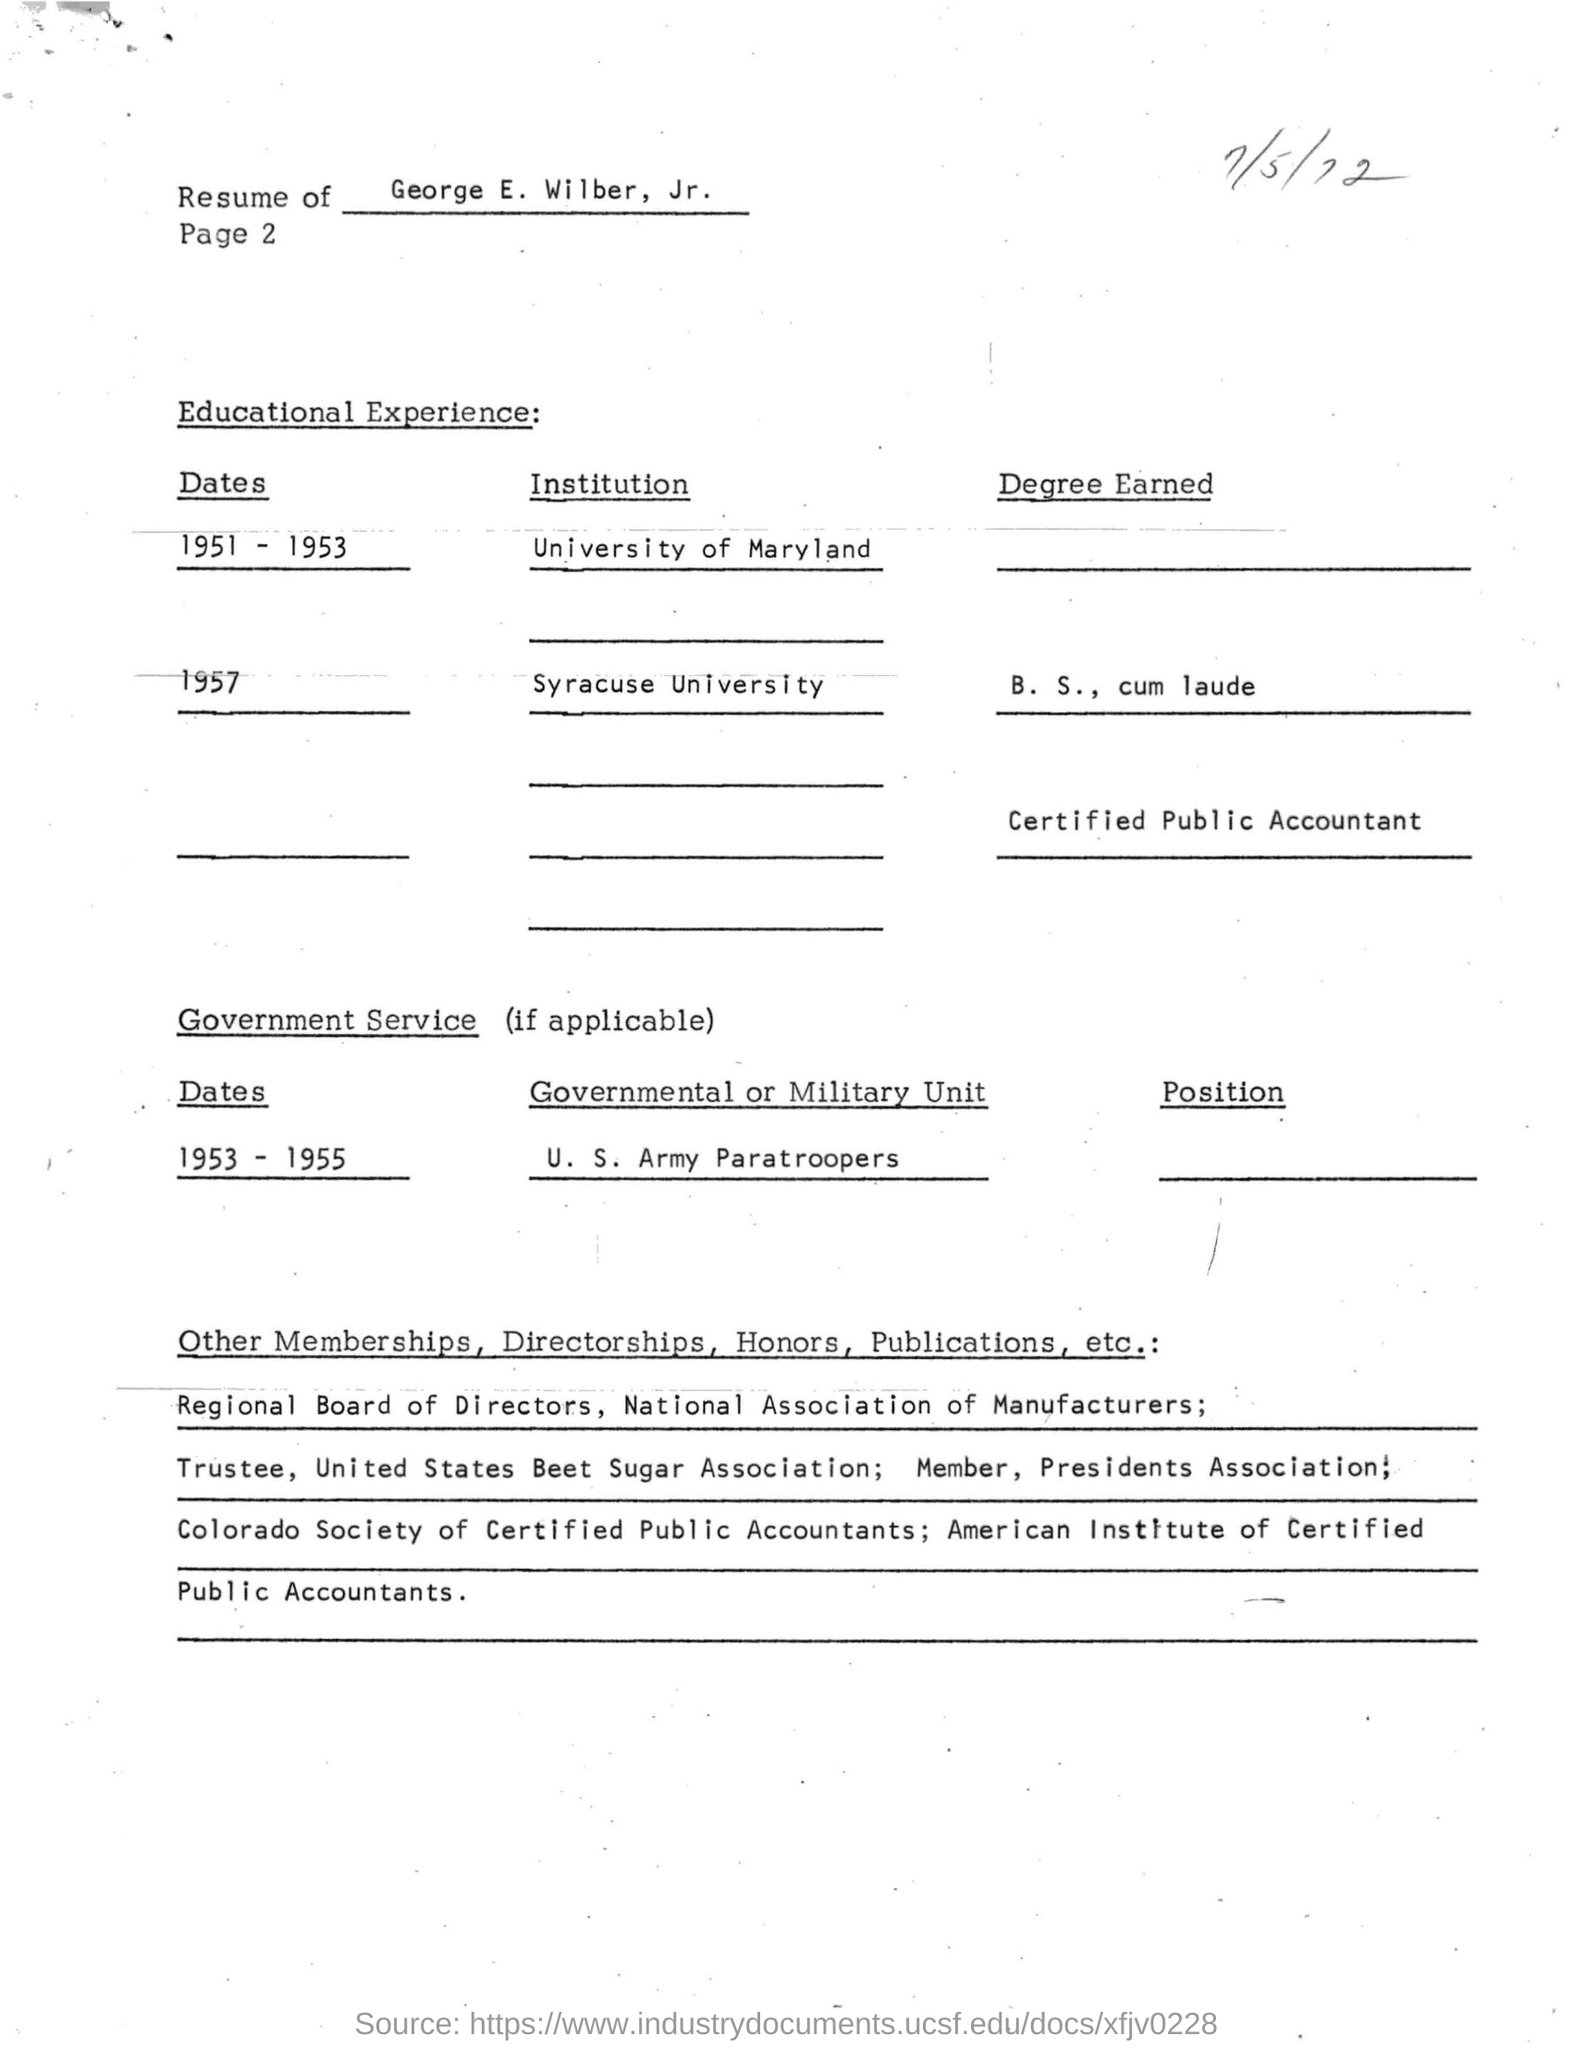Mention a couple of crucial points in this snapshot. George E Wilber, Jr. served in the U.S. Army Paratroopers from 1953 to 1955. The resume of George E Wilber, Jr. is presented. George E. Wilber, Jr. completed his Bachelor of Science degree in 1957. 